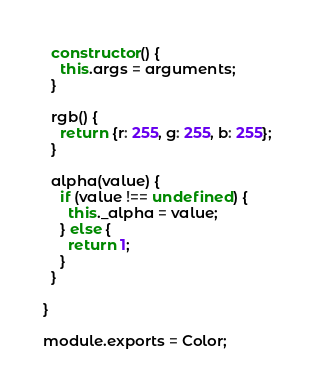<code> <loc_0><loc_0><loc_500><loc_500><_JavaScript_>
  constructor() {
    this.args = arguments;
  }

  rgb() {
    return {r: 255, g: 255, b: 255};
  }

  alpha(value) {
    if (value !== undefined) {
      this._alpha = value;
    } else {
      return 1;
    }
  }

}

module.exports = Color;
</code> 